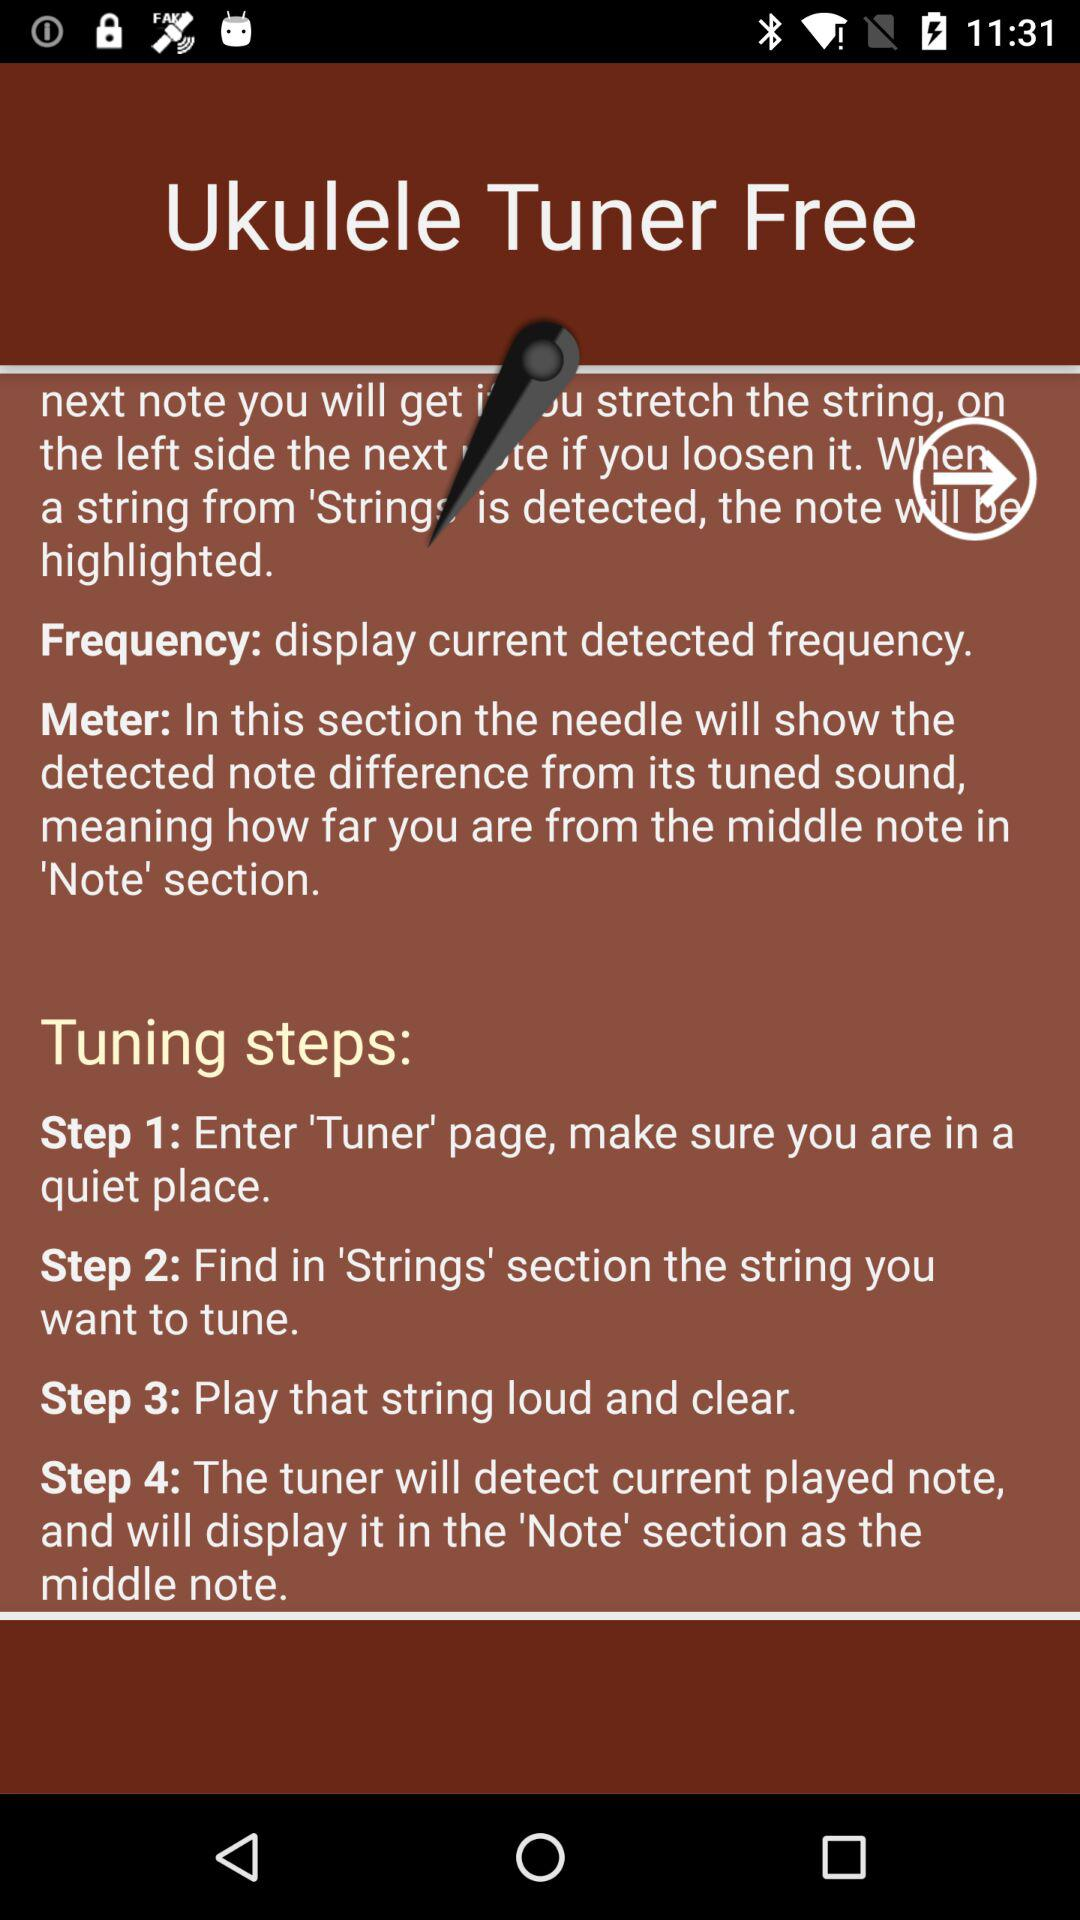How many tuning steps are there?
Answer the question using a single word or phrase. 4 